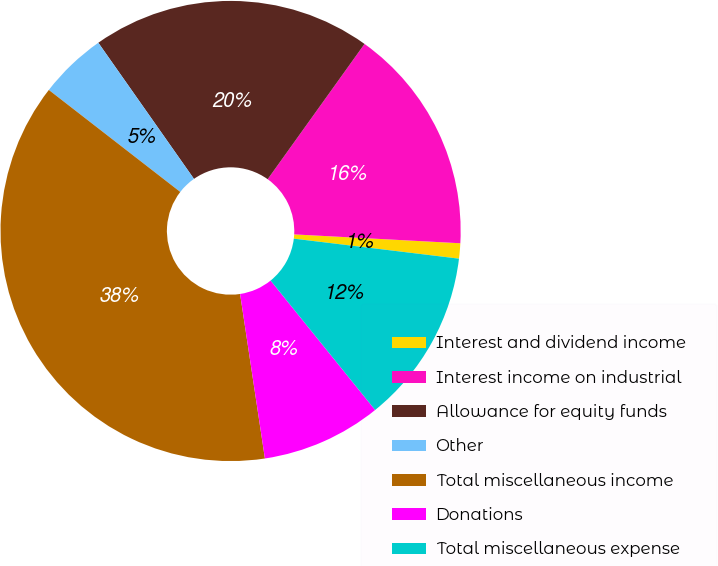<chart> <loc_0><loc_0><loc_500><loc_500><pie_chart><fcel>Interest and dividend income<fcel>Interest income on industrial<fcel>Allowance for equity funds<fcel>Other<fcel>Total miscellaneous income<fcel>Donations<fcel>Total miscellaneous expense<nl><fcel>1.07%<fcel>15.96%<fcel>19.64%<fcel>4.75%<fcel>37.89%<fcel>8.43%<fcel>12.27%<nl></chart> 